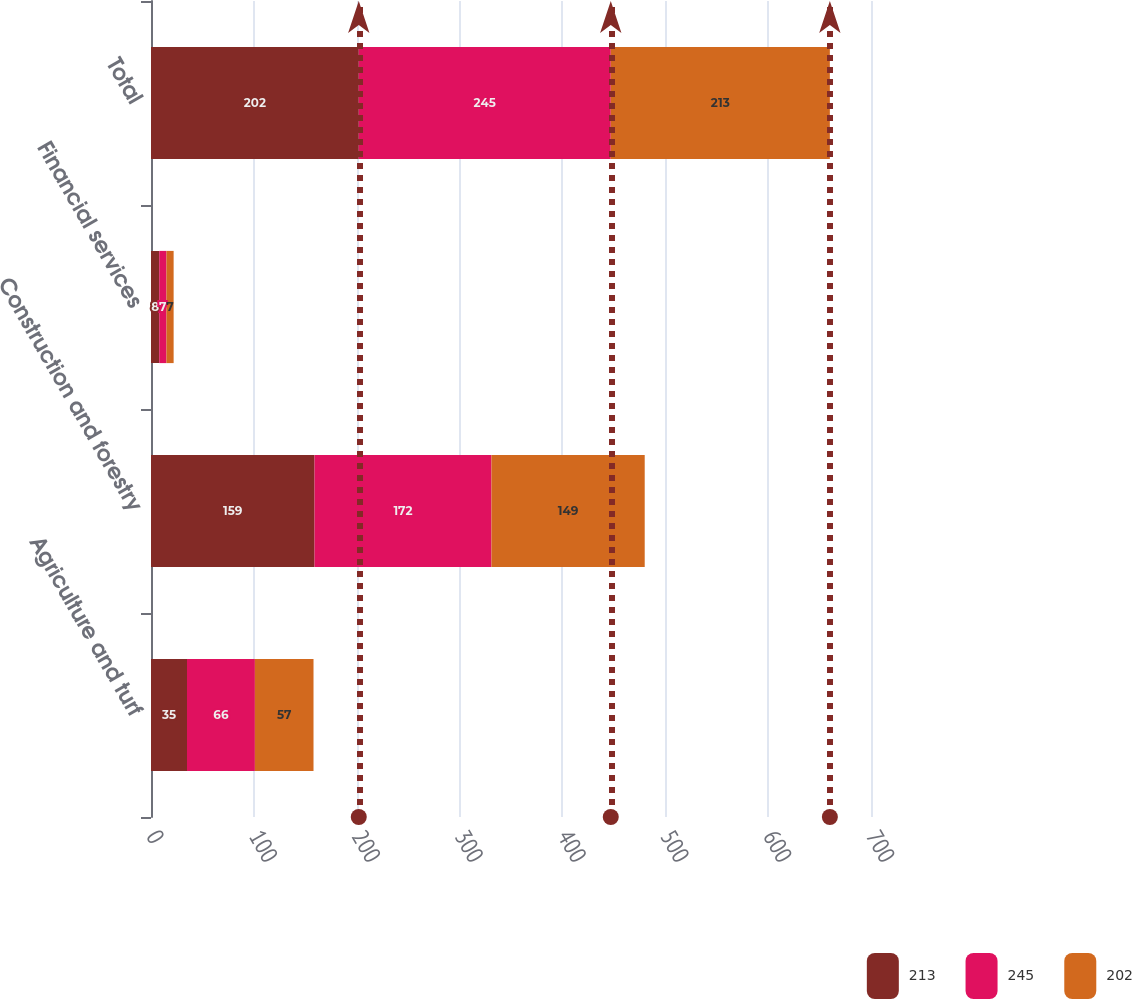Convert chart. <chart><loc_0><loc_0><loc_500><loc_500><stacked_bar_chart><ecel><fcel>Agriculture and turf<fcel>Construction and forestry<fcel>Financial services<fcel>Total<nl><fcel>213<fcel>35<fcel>159<fcel>8<fcel>202<nl><fcel>245<fcel>66<fcel>172<fcel>7<fcel>245<nl><fcel>202<fcel>57<fcel>149<fcel>7<fcel>213<nl></chart> 